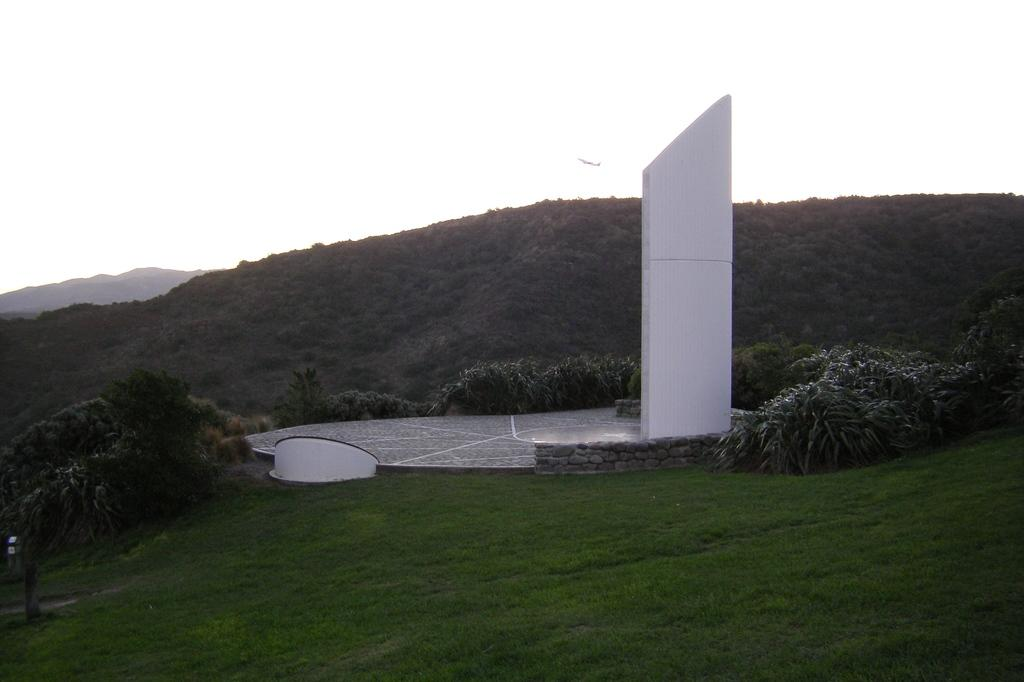What structures are located in the center of the image? There is a pillar and wall in the center of the image. What type of vegetation is present at the bottom of the image? There is grass and plants at the bottom of the image. What can be seen in the background of the image? There are mountains visible in the background of the image. What type of government is depicted in the image? There is no depiction of a government in the image; it features a pillar, wall, grass, plants, and mountains. Can you tell me the account number of the person in the image? There is no person present in the image, so it is not possible to provide an account number. 